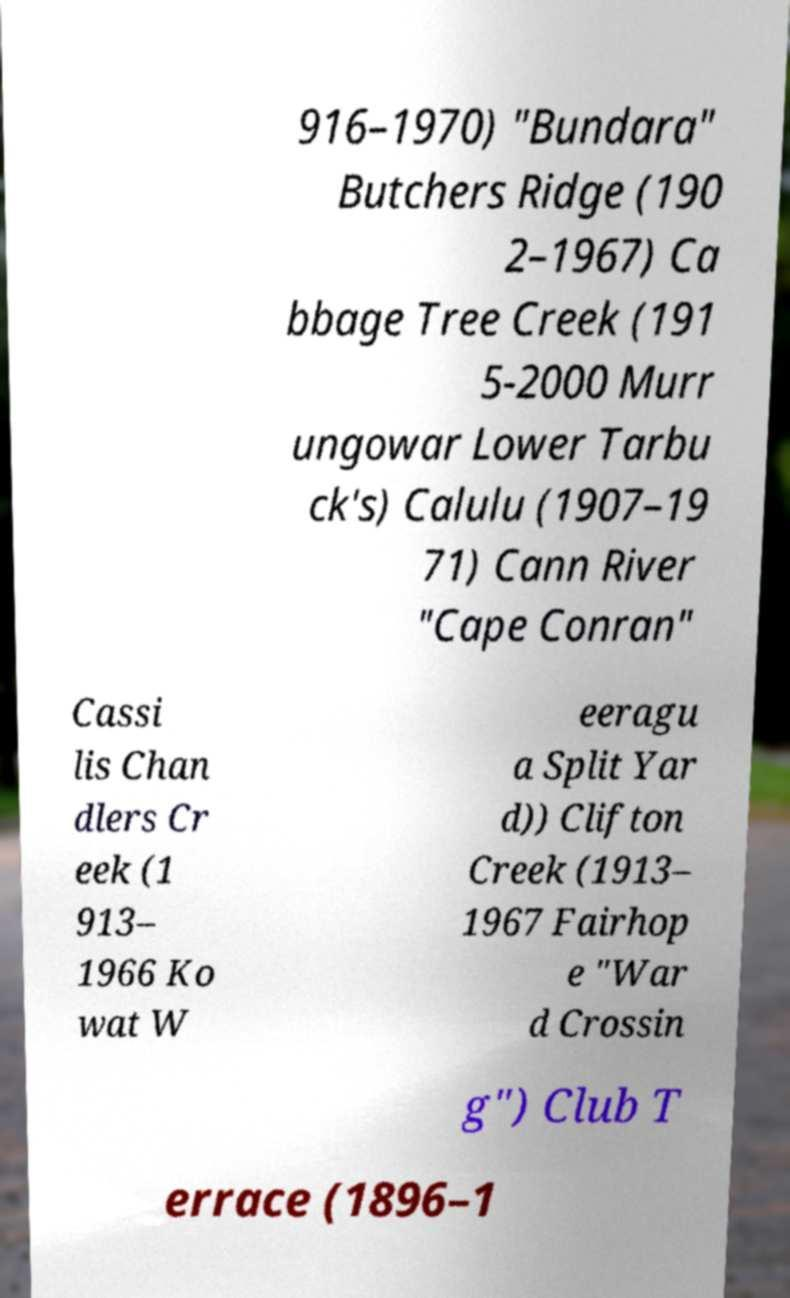I need the written content from this picture converted into text. Can you do that? 916–1970) "Bundara" Butchers Ridge (190 2–1967) Ca bbage Tree Creek (191 5-2000 Murr ungowar Lower Tarbu ck's) Calulu (1907–19 71) Cann River "Cape Conran" Cassi lis Chan dlers Cr eek (1 913– 1966 Ko wat W eeragu a Split Yar d)) Clifton Creek (1913– 1967 Fairhop e "War d Crossin g") Club T errace (1896–1 